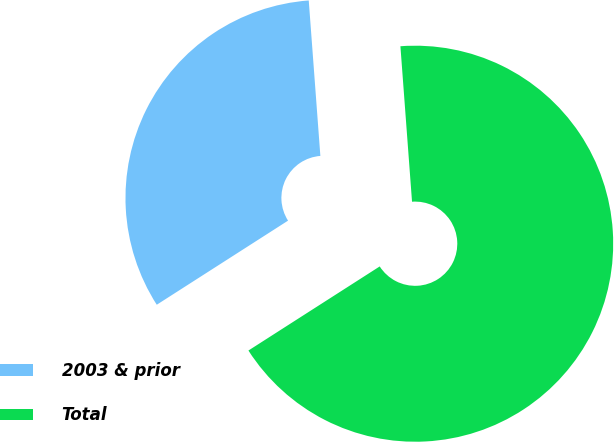<chart> <loc_0><loc_0><loc_500><loc_500><pie_chart><fcel>2003 & prior<fcel>Total<nl><fcel>32.88%<fcel>67.12%<nl></chart> 